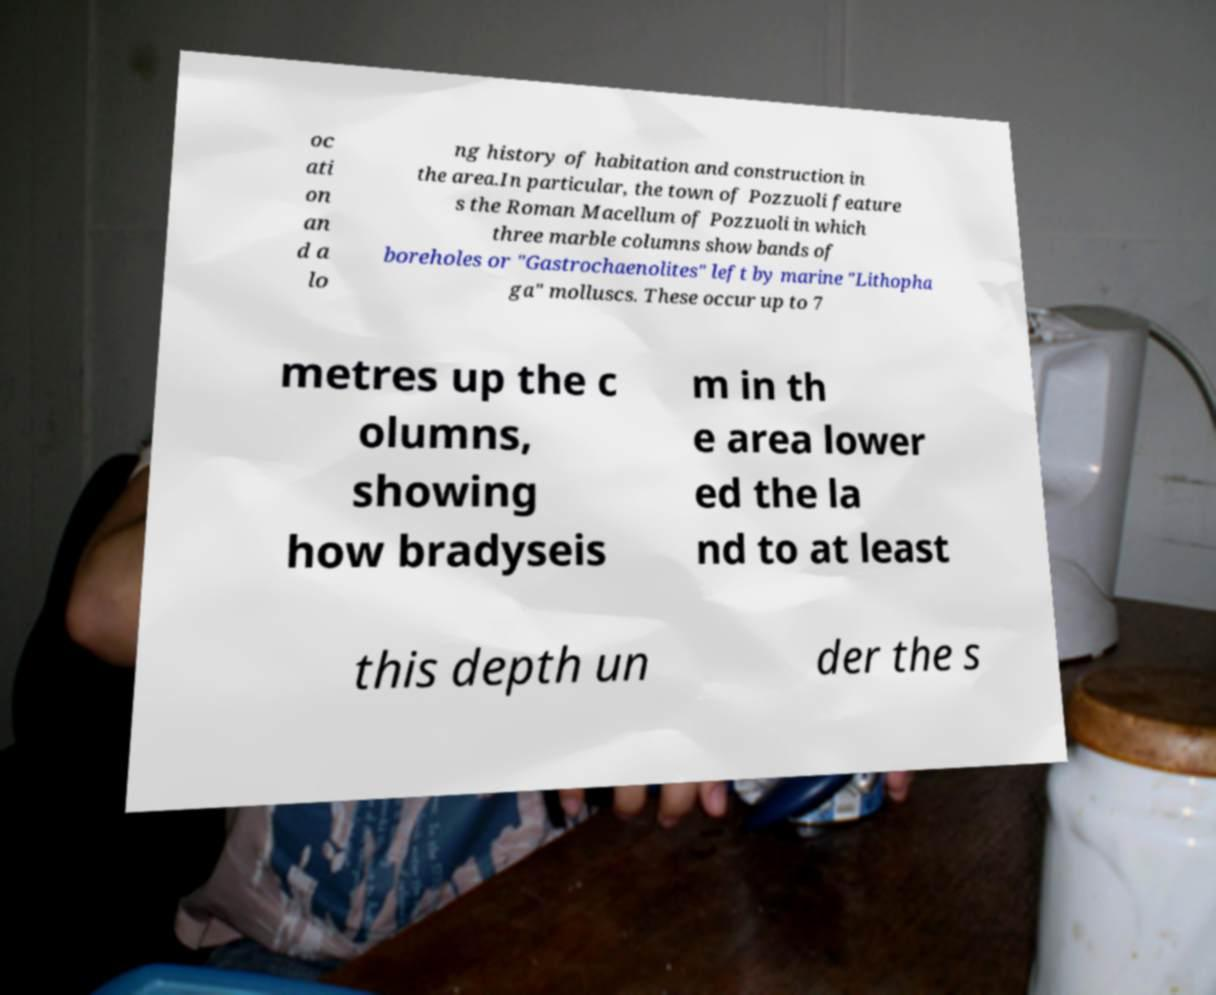Could you extract and type out the text from this image? oc ati on an d a lo ng history of habitation and construction in the area.In particular, the town of Pozzuoli feature s the Roman Macellum of Pozzuoli in which three marble columns show bands of boreholes or "Gastrochaenolites" left by marine "Lithopha ga" molluscs. These occur up to 7 metres up the c olumns, showing how bradyseis m in th e area lower ed the la nd to at least this depth un der the s 